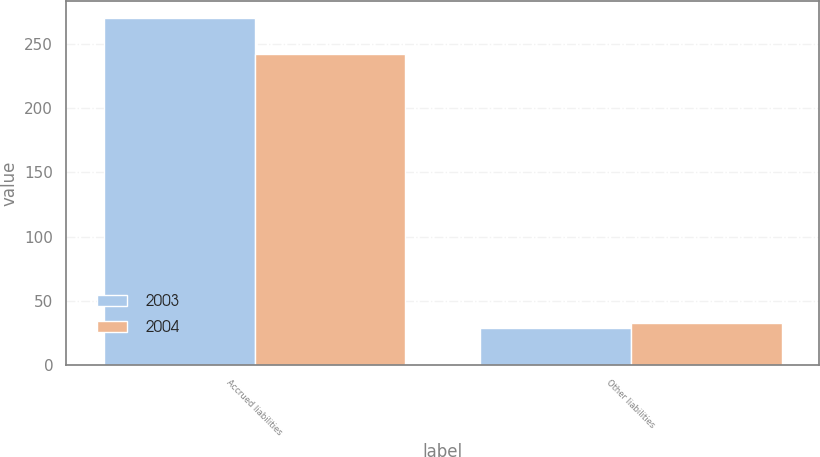Convert chart. <chart><loc_0><loc_0><loc_500><loc_500><stacked_bar_chart><ecel><fcel>Accrued liabilities<fcel>Other liabilities<nl><fcel>2003<fcel>270<fcel>29<nl><fcel>2004<fcel>242<fcel>33<nl></chart> 